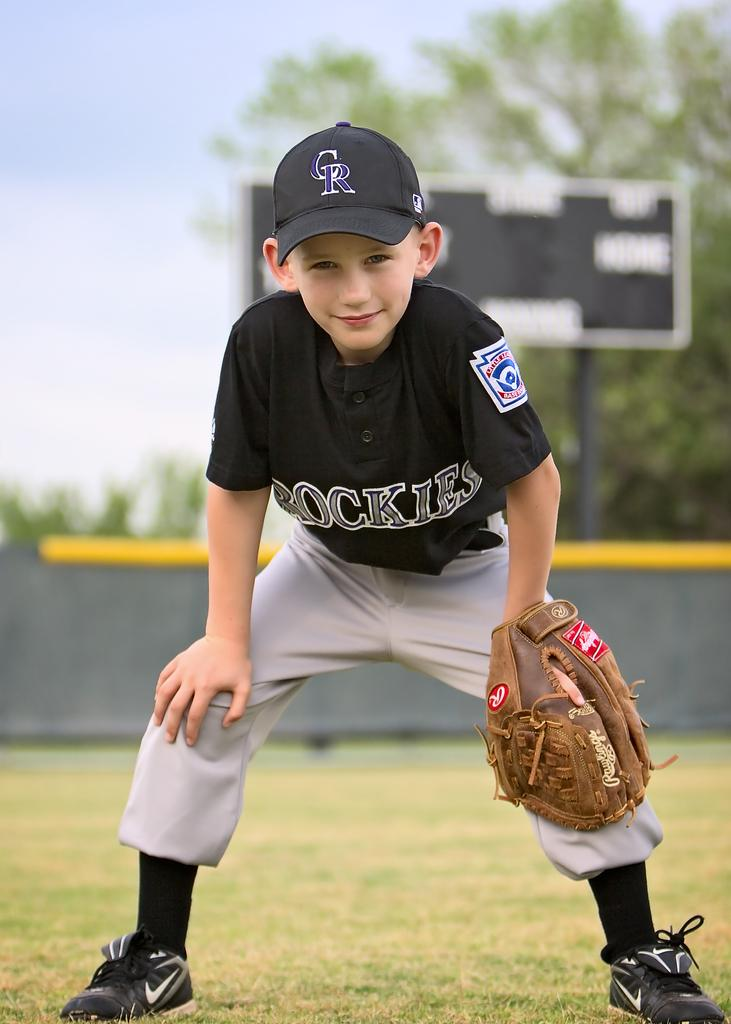<image>
Share a concise interpretation of the image provided. A young boy posing for a picture half crouched with the letters CR on his hat 